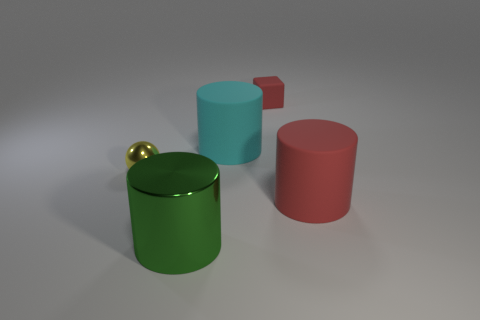Subtract all rubber cylinders. How many cylinders are left? 1 Subtract all red cylinders. How many cylinders are left? 2 Subtract all spheres. How many objects are left? 4 Add 4 green things. How many objects exist? 9 Add 5 brown spheres. How many brown spheres exist? 5 Subtract 0 blue cubes. How many objects are left? 5 Subtract 2 cylinders. How many cylinders are left? 1 Subtract all cyan spheres. Subtract all brown cylinders. How many spheres are left? 1 Subtract all red rubber cylinders. Subtract all small red blocks. How many objects are left? 3 Add 3 cyan rubber objects. How many cyan rubber objects are left? 4 